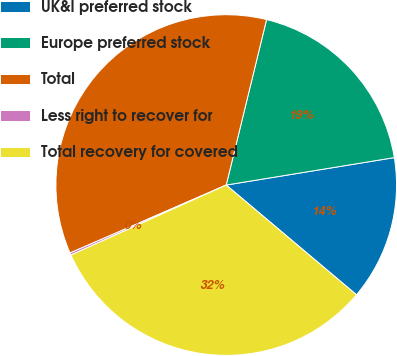Convert chart to OTSL. <chart><loc_0><loc_0><loc_500><loc_500><pie_chart><fcel>UK&I preferred stock<fcel>Europe preferred stock<fcel>Total<fcel>Less right to recover for<fcel>Total recovery for covered<nl><fcel>13.72%<fcel>18.62%<fcel>35.34%<fcel>0.21%<fcel>32.12%<nl></chart> 